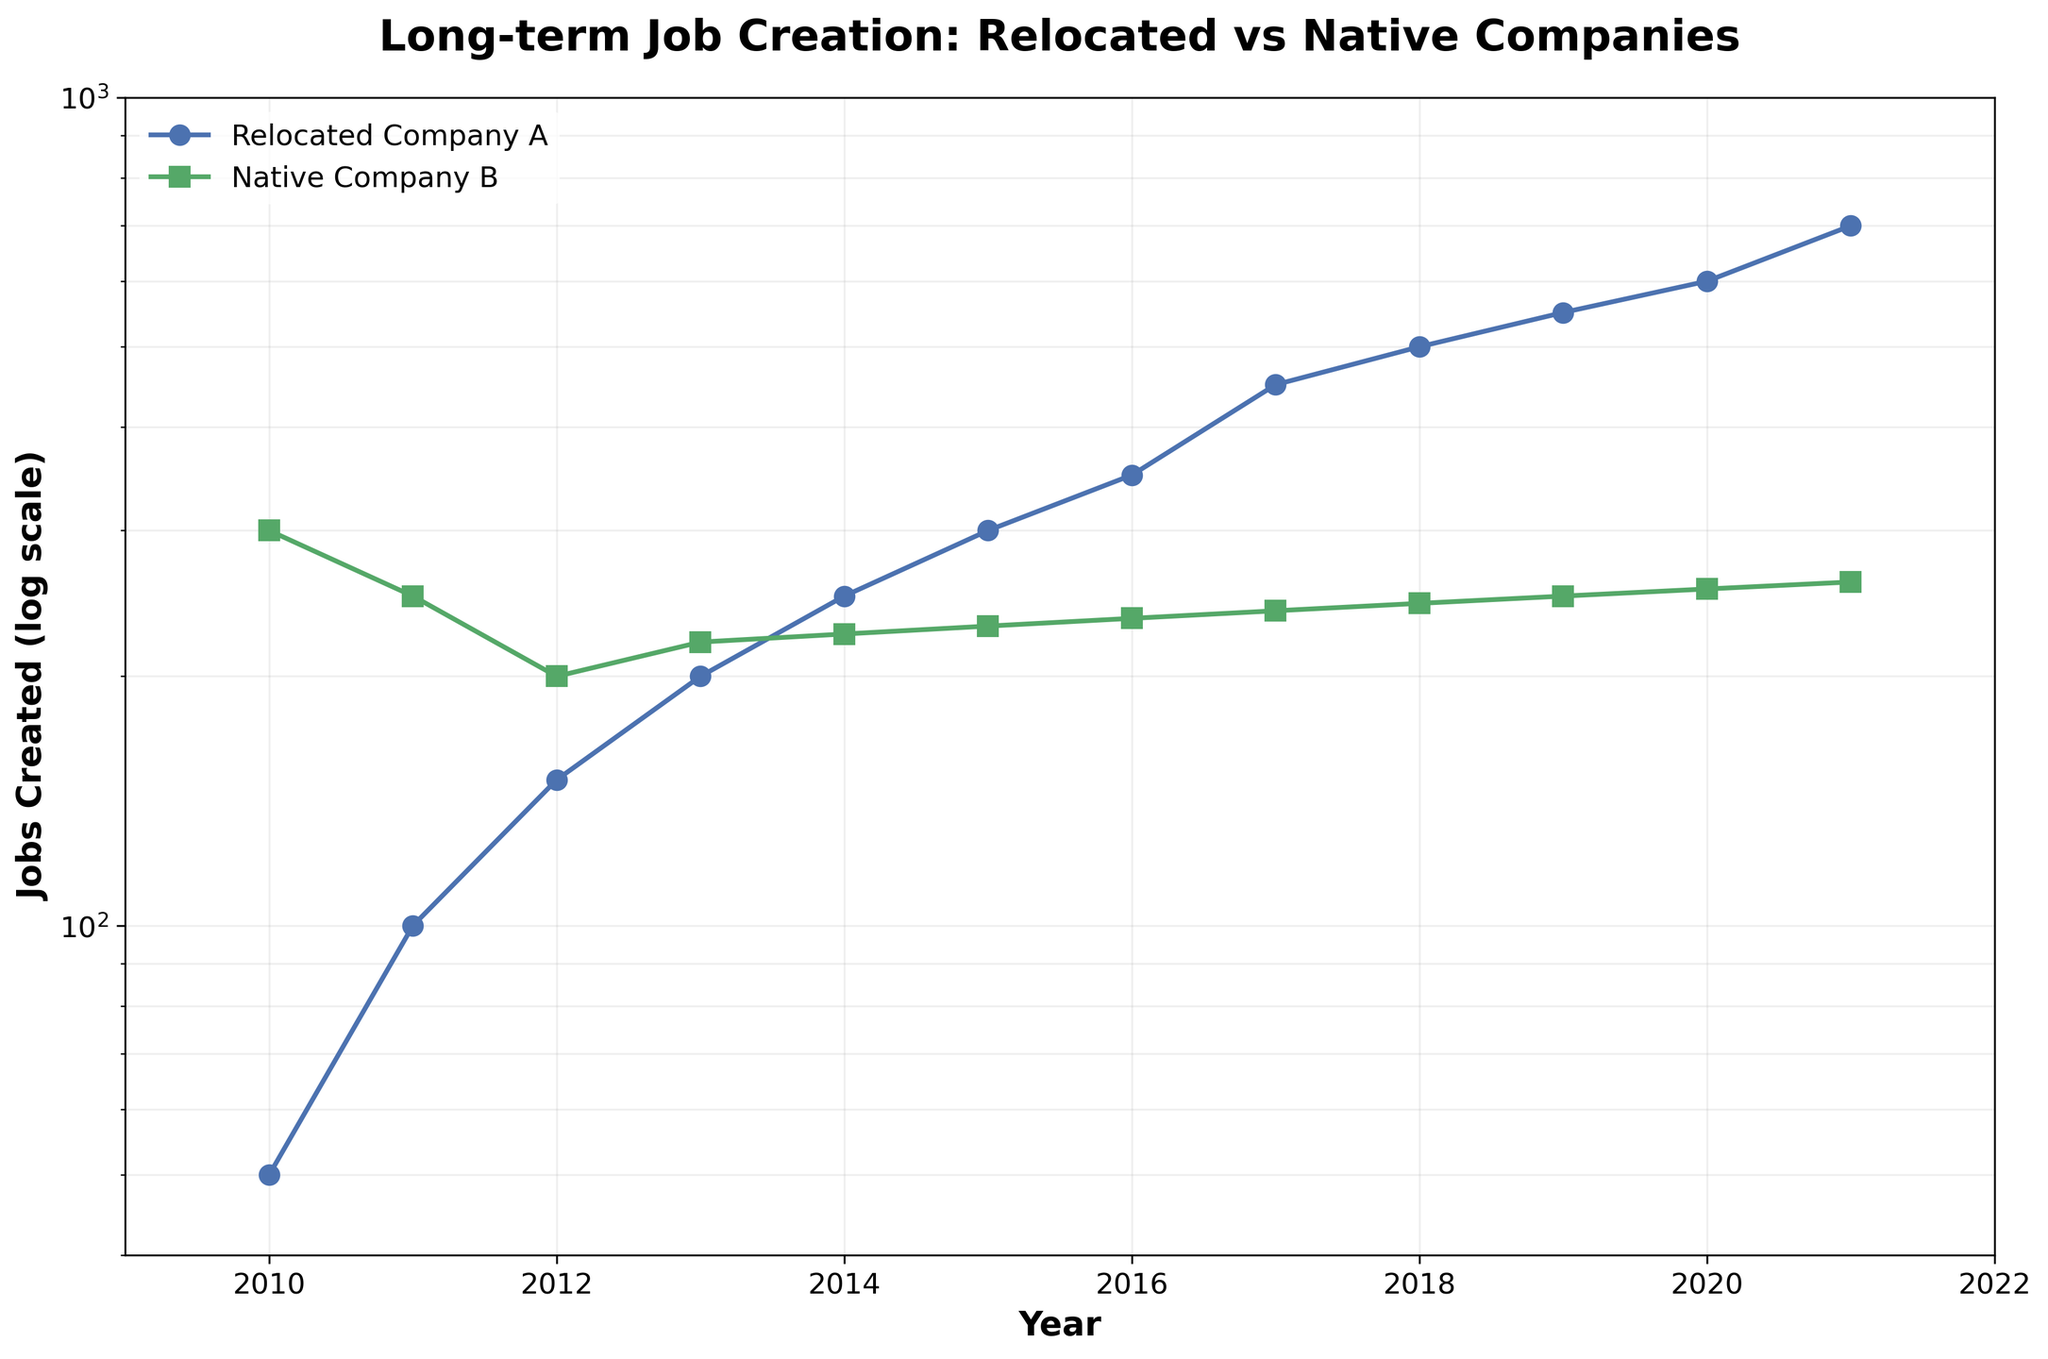How many jobs did Relocated Company A create in 2015? Looking at the point corresponding to 2015 on the line plot for Relocated Company A, the value for jobs created is 300 (noted by the 'o' marker).
Answer: 300 Which company had a higher job creation count in 2013? By comparing the points for the year 2013, we see that Relocated Company A created 200 jobs, while Native Company B created 220 jobs. Therefore, Native Company B had a higher count.
Answer: Native Company B How does job creation in Relocated Company A change over time? Observing Relocated Company A's line, job creation consistently increases from 2010 to 2021. This is indicated by a steady upward trend in the data points on the log scale.
Answer: Increases consistently For which year is the gap in job creation between Relocated Company A and Native Company B the largest? The largest gap appears in 2021, where Relocated Company A created 700 jobs, and Native Company B created 260 jobs, resulting in a gap of 440 jobs.
Answer: 2021 Compare the job creation growth rate between 2010 and 2011 for both companies. For Relocated Company A, jobs created went from 50 to 100, a doubling (100% increase). For Native Company B, jobs created went from 300 to 250, a decrease of 50 jobs (around 16.7% decrease).
Answer: Relocated Company A had a faster growth rate What is the difference in the number of jobs created by Relocated Company A and Native Company B in 2020? In 2020, Relocated Company A created 600 jobs, and Native Company B created 255 jobs. The difference is 600 - 255 = 345.
Answer: 345 How many total jobs did Relocated Company A create between 2010 and 2021? Summing up the jobs created by Relocated Company A from 2010 to 2021: 50 + 100 + 150 + 200 + 250 + 300 + 350 + 450 + 500 + 550 + 600 + 700 = 4200 jobs.
Answer: 4200 In which year does Native Company B's job creation start to decline, according to the plot? Native Company B's job creation starts to decline from 2010 to 2011, where it drops from 300 jobs to 250 jobs.
Answer: 2011 On a log scale, which company shows a more linear trend? A linear trend on a log scale indicates exponential growth. Relocated Company A shows a more linear trend on the log scale, with consistent exponential growth in job creation.
Answer: Relocated Company A What is the median value of jobs created by Native Company B over the period? The job counts in ascending order: 220, 225, 230, 235, 240, 245, 250, 255, 260. The median value, being the middle value in this ordered set, is 235.
Answer: 235 